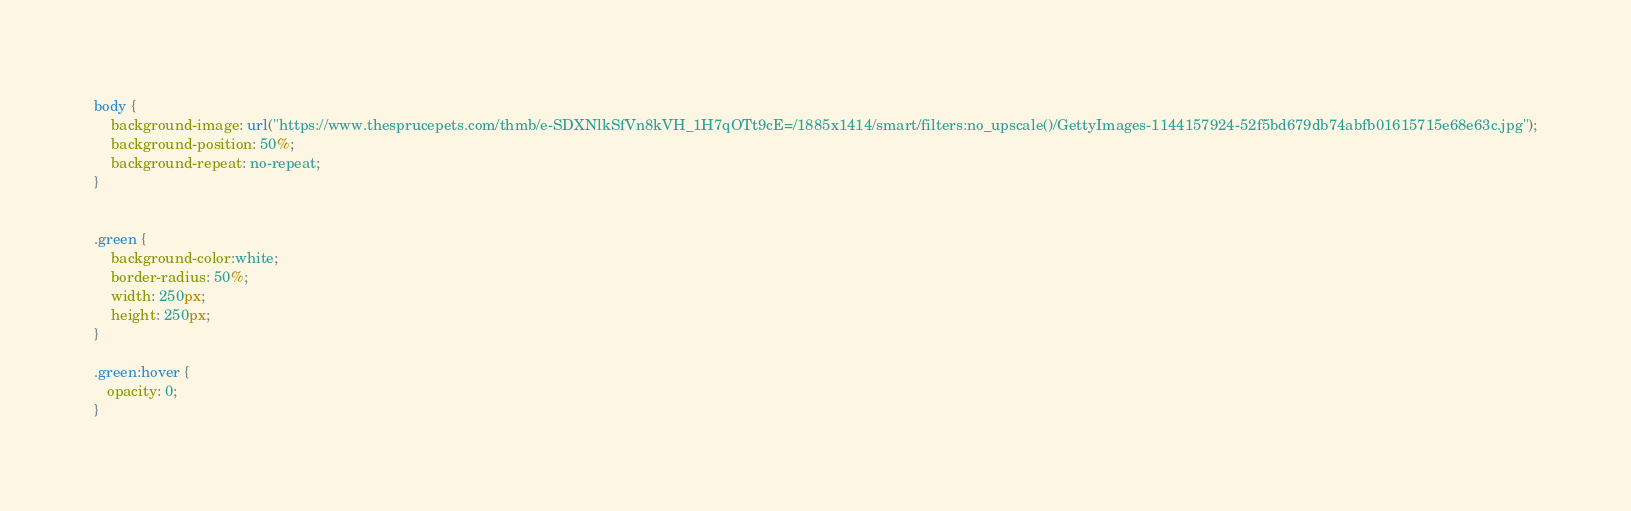<code> <loc_0><loc_0><loc_500><loc_500><_CSS_>body {
    background-image: url("https://www.thesprucepets.com/thmb/e-SDXNlkSfVn8kVH_1H7qOTt9cE=/1885x1414/smart/filters:no_upscale()/GettyImages-1144157924-52f5bd679db74abfb01615715e68e63c.jpg");
    background-position: 50%;
    background-repeat: no-repeat;
}


.green {
    background-color:white;
    border-radius: 50%;
    width: 250px;
    height: 250px;
}

.green:hover {
   opacity: 0;
}

</code> 